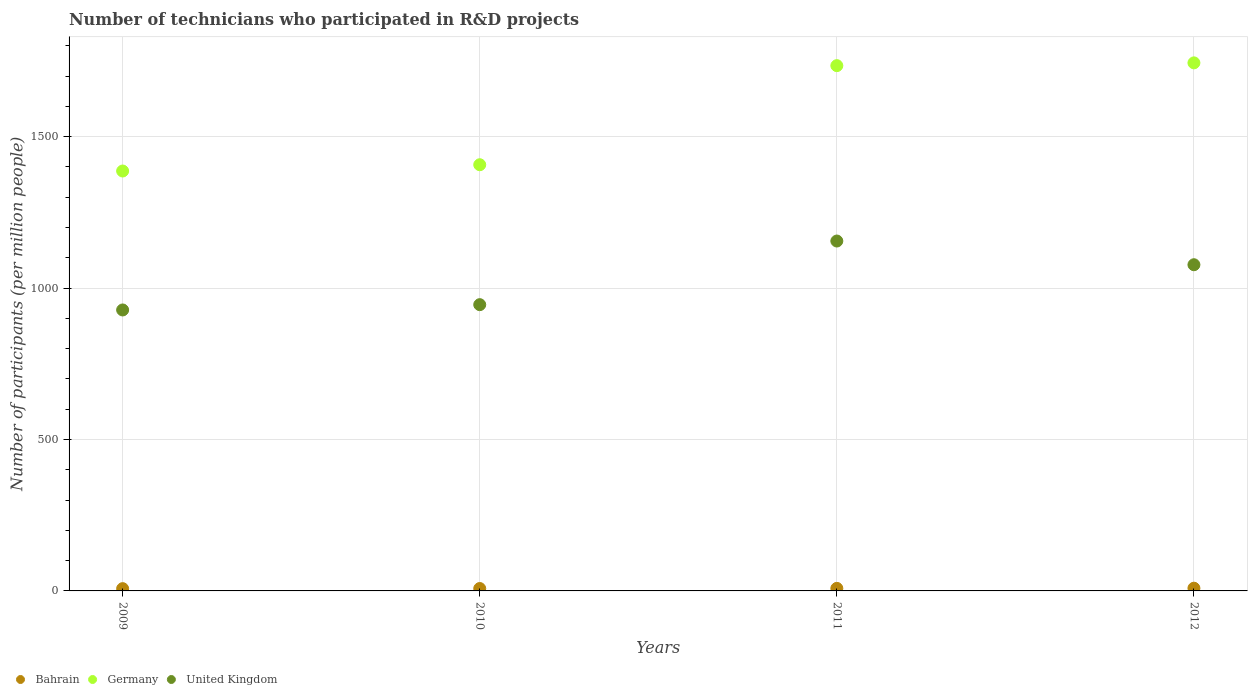Is the number of dotlines equal to the number of legend labels?
Your response must be concise. Yes. What is the number of technicians who participated in R&D projects in United Kingdom in 2010?
Ensure brevity in your answer.  945.36. Across all years, what is the maximum number of technicians who participated in R&D projects in Bahrain?
Your answer should be compact. 9. Across all years, what is the minimum number of technicians who participated in R&D projects in Bahrain?
Keep it short and to the point. 7.52. In which year was the number of technicians who participated in R&D projects in Bahrain maximum?
Your answer should be compact. 2012. What is the total number of technicians who participated in R&D projects in Bahrain in the graph?
Ensure brevity in your answer.  32.87. What is the difference between the number of technicians who participated in R&D projects in Bahrain in 2011 and that in 2012?
Offer a terse response. -0.58. What is the difference between the number of technicians who participated in R&D projects in Germany in 2011 and the number of technicians who participated in R&D projects in Bahrain in 2012?
Your answer should be very brief. 1725.73. What is the average number of technicians who participated in R&D projects in Germany per year?
Your response must be concise. 1568.21. In the year 2009, what is the difference between the number of technicians who participated in R&D projects in Bahrain and number of technicians who participated in R&D projects in United Kingdom?
Offer a very short reply. -920.36. In how many years, is the number of technicians who participated in R&D projects in Germany greater than 900?
Keep it short and to the point. 4. What is the ratio of the number of technicians who participated in R&D projects in Bahrain in 2011 to that in 2012?
Provide a short and direct response. 0.94. What is the difference between the highest and the second highest number of technicians who participated in R&D projects in Bahrain?
Ensure brevity in your answer.  0.58. What is the difference between the highest and the lowest number of technicians who participated in R&D projects in Bahrain?
Your response must be concise. 1.48. Is the sum of the number of technicians who participated in R&D projects in Bahrain in 2011 and 2012 greater than the maximum number of technicians who participated in R&D projects in United Kingdom across all years?
Keep it short and to the point. No. Is it the case that in every year, the sum of the number of technicians who participated in R&D projects in Germany and number of technicians who participated in R&D projects in Bahrain  is greater than the number of technicians who participated in R&D projects in United Kingdom?
Offer a very short reply. Yes. Is the number of technicians who participated in R&D projects in Germany strictly greater than the number of technicians who participated in R&D projects in Bahrain over the years?
Provide a short and direct response. Yes. Is the number of technicians who participated in R&D projects in Germany strictly less than the number of technicians who participated in R&D projects in Bahrain over the years?
Your response must be concise. No. How many years are there in the graph?
Your answer should be very brief. 4. Does the graph contain any zero values?
Keep it short and to the point. No. Does the graph contain grids?
Give a very brief answer. Yes. Where does the legend appear in the graph?
Your answer should be compact. Bottom left. How many legend labels are there?
Keep it short and to the point. 3. How are the legend labels stacked?
Make the answer very short. Horizontal. What is the title of the graph?
Provide a short and direct response. Number of technicians who participated in R&D projects. What is the label or title of the Y-axis?
Make the answer very short. Number of participants (per million people). What is the Number of participants (per million people) in Bahrain in 2009?
Provide a succinct answer. 7.52. What is the Number of participants (per million people) of Germany in 2009?
Give a very brief answer. 1386.74. What is the Number of participants (per million people) in United Kingdom in 2009?
Provide a succinct answer. 927.88. What is the Number of participants (per million people) of Bahrain in 2010?
Provide a succinct answer. 7.93. What is the Number of participants (per million people) in Germany in 2010?
Your answer should be compact. 1407.48. What is the Number of participants (per million people) in United Kingdom in 2010?
Your answer should be compact. 945.36. What is the Number of participants (per million people) of Bahrain in 2011?
Your answer should be very brief. 8.42. What is the Number of participants (per million people) of Germany in 2011?
Keep it short and to the point. 1734.73. What is the Number of participants (per million people) of United Kingdom in 2011?
Provide a short and direct response. 1155.52. What is the Number of participants (per million people) in Bahrain in 2012?
Provide a succinct answer. 9. What is the Number of participants (per million people) of Germany in 2012?
Provide a short and direct response. 1743.9. What is the Number of participants (per million people) in United Kingdom in 2012?
Ensure brevity in your answer.  1077.23. Across all years, what is the maximum Number of participants (per million people) of Bahrain?
Your answer should be compact. 9. Across all years, what is the maximum Number of participants (per million people) of Germany?
Make the answer very short. 1743.9. Across all years, what is the maximum Number of participants (per million people) of United Kingdom?
Give a very brief answer. 1155.52. Across all years, what is the minimum Number of participants (per million people) of Bahrain?
Provide a succinct answer. 7.52. Across all years, what is the minimum Number of participants (per million people) in Germany?
Make the answer very short. 1386.74. Across all years, what is the minimum Number of participants (per million people) of United Kingdom?
Your answer should be very brief. 927.88. What is the total Number of participants (per million people) in Bahrain in the graph?
Your response must be concise. 32.87. What is the total Number of participants (per million people) of Germany in the graph?
Make the answer very short. 6272.86. What is the total Number of participants (per million people) of United Kingdom in the graph?
Your response must be concise. 4106. What is the difference between the Number of participants (per million people) in Bahrain in 2009 and that in 2010?
Ensure brevity in your answer.  -0.41. What is the difference between the Number of participants (per million people) in Germany in 2009 and that in 2010?
Your answer should be compact. -20.74. What is the difference between the Number of participants (per million people) in United Kingdom in 2009 and that in 2010?
Your answer should be compact. -17.48. What is the difference between the Number of participants (per million people) in Bahrain in 2009 and that in 2011?
Keep it short and to the point. -0.9. What is the difference between the Number of participants (per million people) in Germany in 2009 and that in 2011?
Offer a terse response. -347.98. What is the difference between the Number of participants (per million people) of United Kingdom in 2009 and that in 2011?
Provide a succinct answer. -227.64. What is the difference between the Number of participants (per million people) of Bahrain in 2009 and that in 2012?
Make the answer very short. -1.48. What is the difference between the Number of participants (per million people) of Germany in 2009 and that in 2012?
Provide a succinct answer. -357.16. What is the difference between the Number of participants (per million people) in United Kingdom in 2009 and that in 2012?
Keep it short and to the point. -149.35. What is the difference between the Number of participants (per million people) in Bahrain in 2010 and that in 2011?
Your response must be concise. -0.49. What is the difference between the Number of participants (per million people) of Germany in 2010 and that in 2011?
Provide a short and direct response. -327.24. What is the difference between the Number of participants (per million people) in United Kingdom in 2010 and that in 2011?
Ensure brevity in your answer.  -210.16. What is the difference between the Number of participants (per million people) of Bahrain in 2010 and that in 2012?
Give a very brief answer. -1.07. What is the difference between the Number of participants (per million people) in Germany in 2010 and that in 2012?
Offer a terse response. -336.42. What is the difference between the Number of participants (per million people) of United Kingdom in 2010 and that in 2012?
Give a very brief answer. -131.87. What is the difference between the Number of participants (per million people) of Bahrain in 2011 and that in 2012?
Your answer should be very brief. -0.58. What is the difference between the Number of participants (per million people) of Germany in 2011 and that in 2012?
Provide a short and direct response. -9.18. What is the difference between the Number of participants (per million people) of United Kingdom in 2011 and that in 2012?
Your response must be concise. 78.29. What is the difference between the Number of participants (per million people) of Bahrain in 2009 and the Number of participants (per million people) of Germany in 2010?
Ensure brevity in your answer.  -1399.96. What is the difference between the Number of participants (per million people) of Bahrain in 2009 and the Number of participants (per million people) of United Kingdom in 2010?
Offer a very short reply. -937.84. What is the difference between the Number of participants (per million people) of Germany in 2009 and the Number of participants (per million people) of United Kingdom in 2010?
Provide a short and direct response. 441.38. What is the difference between the Number of participants (per million people) in Bahrain in 2009 and the Number of participants (per million people) in Germany in 2011?
Provide a short and direct response. -1727.21. What is the difference between the Number of participants (per million people) of Bahrain in 2009 and the Number of participants (per million people) of United Kingdom in 2011?
Your answer should be very brief. -1148. What is the difference between the Number of participants (per million people) in Germany in 2009 and the Number of participants (per million people) in United Kingdom in 2011?
Offer a terse response. 231.22. What is the difference between the Number of participants (per million people) in Bahrain in 2009 and the Number of participants (per million people) in Germany in 2012?
Your response must be concise. -1736.38. What is the difference between the Number of participants (per million people) in Bahrain in 2009 and the Number of participants (per million people) in United Kingdom in 2012?
Your response must be concise. -1069.71. What is the difference between the Number of participants (per million people) of Germany in 2009 and the Number of participants (per million people) of United Kingdom in 2012?
Ensure brevity in your answer.  309.51. What is the difference between the Number of participants (per million people) of Bahrain in 2010 and the Number of participants (per million people) of Germany in 2011?
Provide a short and direct response. -1726.8. What is the difference between the Number of participants (per million people) of Bahrain in 2010 and the Number of participants (per million people) of United Kingdom in 2011?
Your answer should be very brief. -1147.6. What is the difference between the Number of participants (per million people) of Germany in 2010 and the Number of participants (per million people) of United Kingdom in 2011?
Give a very brief answer. 251.96. What is the difference between the Number of participants (per million people) in Bahrain in 2010 and the Number of participants (per million people) in Germany in 2012?
Your answer should be compact. -1735.98. What is the difference between the Number of participants (per million people) of Bahrain in 2010 and the Number of participants (per million people) of United Kingdom in 2012?
Offer a terse response. -1069.3. What is the difference between the Number of participants (per million people) in Germany in 2010 and the Number of participants (per million people) in United Kingdom in 2012?
Offer a terse response. 330.25. What is the difference between the Number of participants (per million people) in Bahrain in 2011 and the Number of participants (per million people) in Germany in 2012?
Keep it short and to the point. -1735.48. What is the difference between the Number of participants (per million people) in Bahrain in 2011 and the Number of participants (per million people) in United Kingdom in 2012?
Your response must be concise. -1068.81. What is the difference between the Number of participants (per million people) in Germany in 2011 and the Number of participants (per million people) in United Kingdom in 2012?
Ensure brevity in your answer.  657.5. What is the average Number of participants (per million people) in Bahrain per year?
Offer a very short reply. 8.22. What is the average Number of participants (per million people) in Germany per year?
Provide a short and direct response. 1568.21. What is the average Number of participants (per million people) of United Kingdom per year?
Give a very brief answer. 1026.5. In the year 2009, what is the difference between the Number of participants (per million people) of Bahrain and Number of participants (per million people) of Germany?
Your answer should be very brief. -1379.22. In the year 2009, what is the difference between the Number of participants (per million people) of Bahrain and Number of participants (per million people) of United Kingdom?
Offer a terse response. -920.36. In the year 2009, what is the difference between the Number of participants (per million people) in Germany and Number of participants (per million people) in United Kingdom?
Your answer should be very brief. 458.86. In the year 2010, what is the difference between the Number of participants (per million people) of Bahrain and Number of participants (per million people) of Germany?
Your response must be concise. -1399.55. In the year 2010, what is the difference between the Number of participants (per million people) in Bahrain and Number of participants (per million people) in United Kingdom?
Provide a short and direct response. -937.44. In the year 2010, what is the difference between the Number of participants (per million people) in Germany and Number of participants (per million people) in United Kingdom?
Offer a terse response. 462.12. In the year 2011, what is the difference between the Number of participants (per million people) in Bahrain and Number of participants (per million people) in Germany?
Your answer should be compact. -1726.3. In the year 2011, what is the difference between the Number of participants (per million people) of Bahrain and Number of participants (per million people) of United Kingdom?
Give a very brief answer. -1147.1. In the year 2011, what is the difference between the Number of participants (per million people) in Germany and Number of participants (per million people) in United Kingdom?
Your answer should be compact. 579.2. In the year 2012, what is the difference between the Number of participants (per million people) of Bahrain and Number of participants (per million people) of Germany?
Your response must be concise. -1734.91. In the year 2012, what is the difference between the Number of participants (per million people) of Bahrain and Number of participants (per million people) of United Kingdom?
Your response must be concise. -1068.23. In the year 2012, what is the difference between the Number of participants (per million people) of Germany and Number of participants (per million people) of United Kingdom?
Your response must be concise. 666.67. What is the ratio of the Number of participants (per million people) of Bahrain in 2009 to that in 2010?
Make the answer very short. 0.95. What is the ratio of the Number of participants (per million people) in United Kingdom in 2009 to that in 2010?
Your answer should be very brief. 0.98. What is the ratio of the Number of participants (per million people) of Bahrain in 2009 to that in 2011?
Your answer should be very brief. 0.89. What is the ratio of the Number of participants (per million people) in Germany in 2009 to that in 2011?
Provide a short and direct response. 0.8. What is the ratio of the Number of participants (per million people) in United Kingdom in 2009 to that in 2011?
Offer a very short reply. 0.8. What is the ratio of the Number of participants (per million people) in Bahrain in 2009 to that in 2012?
Keep it short and to the point. 0.84. What is the ratio of the Number of participants (per million people) of Germany in 2009 to that in 2012?
Keep it short and to the point. 0.8. What is the ratio of the Number of participants (per million people) of United Kingdom in 2009 to that in 2012?
Provide a succinct answer. 0.86. What is the ratio of the Number of participants (per million people) of Bahrain in 2010 to that in 2011?
Provide a succinct answer. 0.94. What is the ratio of the Number of participants (per million people) in Germany in 2010 to that in 2011?
Give a very brief answer. 0.81. What is the ratio of the Number of participants (per million people) in United Kingdom in 2010 to that in 2011?
Offer a terse response. 0.82. What is the ratio of the Number of participants (per million people) of Bahrain in 2010 to that in 2012?
Make the answer very short. 0.88. What is the ratio of the Number of participants (per million people) in Germany in 2010 to that in 2012?
Keep it short and to the point. 0.81. What is the ratio of the Number of participants (per million people) in United Kingdom in 2010 to that in 2012?
Your response must be concise. 0.88. What is the ratio of the Number of participants (per million people) of Bahrain in 2011 to that in 2012?
Keep it short and to the point. 0.94. What is the ratio of the Number of participants (per million people) in United Kingdom in 2011 to that in 2012?
Give a very brief answer. 1.07. What is the difference between the highest and the second highest Number of participants (per million people) of Bahrain?
Your answer should be very brief. 0.58. What is the difference between the highest and the second highest Number of participants (per million people) in Germany?
Your response must be concise. 9.18. What is the difference between the highest and the second highest Number of participants (per million people) of United Kingdom?
Give a very brief answer. 78.29. What is the difference between the highest and the lowest Number of participants (per million people) in Bahrain?
Offer a very short reply. 1.48. What is the difference between the highest and the lowest Number of participants (per million people) of Germany?
Keep it short and to the point. 357.16. What is the difference between the highest and the lowest Number of participants (per million people) of United Kingdom?
Offer a very short reply. 227.64. 